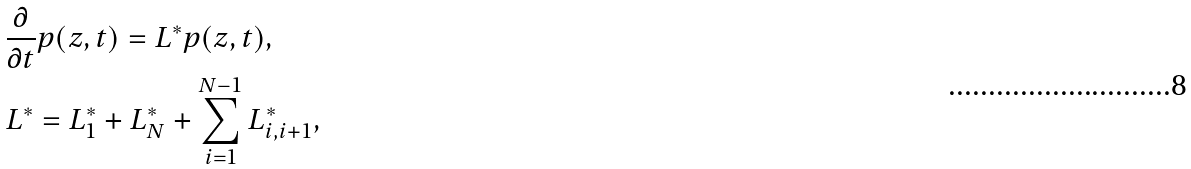Convert formula to latex. <formula><loc_0><loc_0><loc_500><loc_500>& \frac { \partial } { \partial t } p ( z , t ) = L ^ { * } p ( z , t ) , \\ & L ^ { * } = L ^ { * } _ { 1 } + L ^ { * } _ { N } + \sum _ { i = 1 } ^ { N - 1 } L ^ { * } _ { i , i + 1 } ,</formula> 